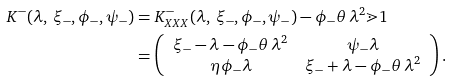<formula> <loc_0><loc_0><loc_500><loc_500>K ^ { - } ( \lambda , \, \xi _ { - } , \phi _ { - } , \psi _ { - } ) & = K ^ { - } _ { X X X } ( \lambda , \, \xi _ { - } , \phi _ { - } , \psi _ { - } ) - \phi _ { - } \theta \, \lambda ^ { 2 } \mathbb { m } { 1 } \\ & = \left ( \begin{array} { c c } \xi _ { - } - \lambda - \phi _ { - } \theta \, \lambda ^ { 2 } & \psi _ { - } \lambda \\ \eta \phi _ { - } \lambda & \xi _ { - } + \lambda - \phi _ { - } \theta \, \lambda ^ { 2 } \end{array} \right ) .</formula> 